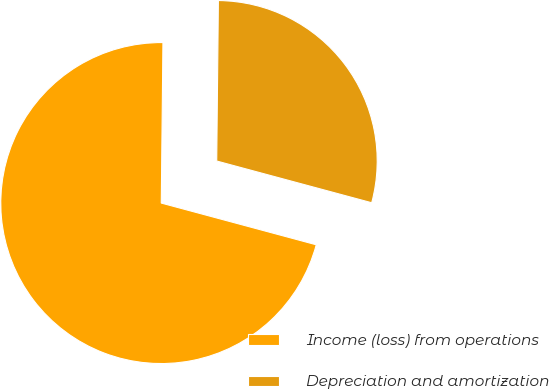Convert chart to OTSL. <chart><loc_0><loc_0><loc_500><loc_500><pie_chart><fcel>Income (loss) from operations<fcel>Depreciation and amortization<nl><fcel>70.98%<fcel>29.02%<nl></chart> 